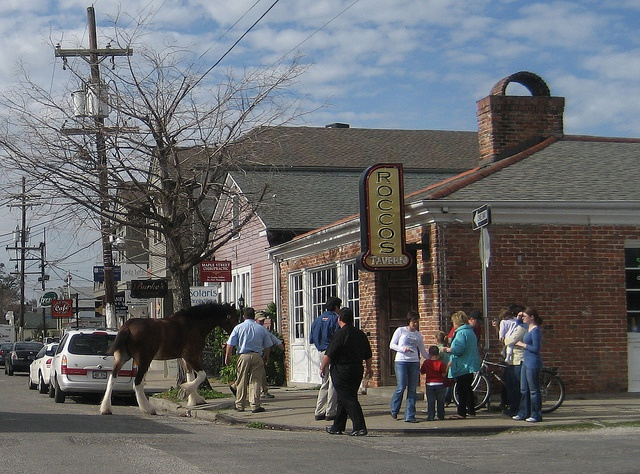Describe the objects in this image and their specific colors. I can see horse in darkgray, black, and gray tones, car in darkgray, black, gray, and lightgray tones, people in darkgray, black, gray, and maroon tones, people in darkgray, gray, and black tones, and people in darkgray, black, gray, and lavender tones in this image. 